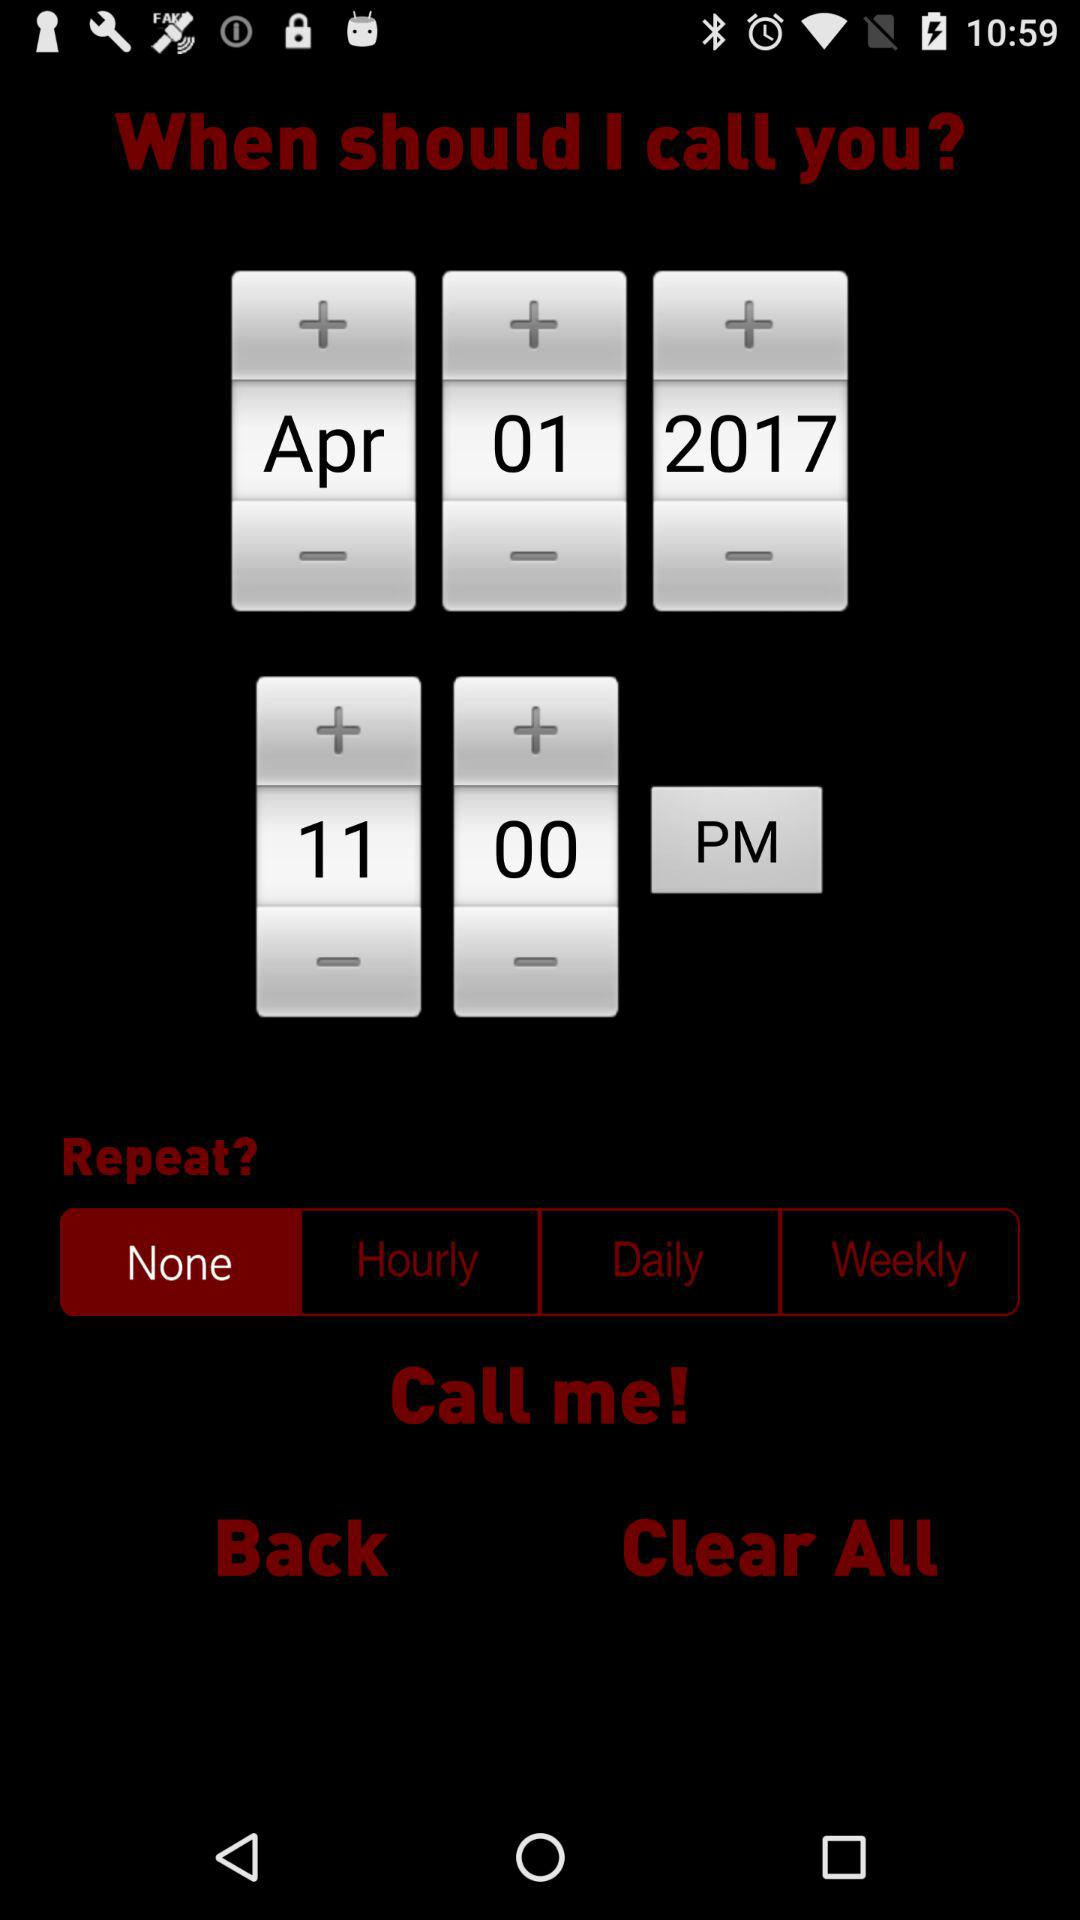Which day of the week falls on April 1, 2017.
When the provided information is insufficient, respond with <no answer>. <no answer> 